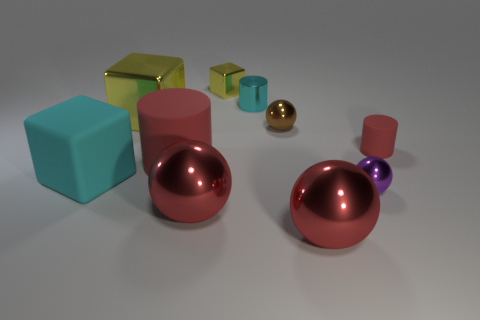Subtract all red cylinders. How many were subtracted if there are1red cylinders left? 1 Subtract all cylinders. How many objects are left? 7 Subtract 3 cylinders. How many cylinders are left? 0 Subtract all cyan blocks. Subtract all green cylinders. How many blocks are left? 2 Subtract all purple cylinders. How many cyan blocks are left? 1 Subtract all brown metallic blocks. Subtract all tiny brown shiny objects. How many objects are left? 9 Add 7 red matte cylinders. How many red matte cylinders are left? 9 Add 1 shiny cubes. How many shiny cubes exist? 3 Subtract all cyan blocks. How many blocks are left? 2 Subtract all brown spheres. How many spheres are left? 3 